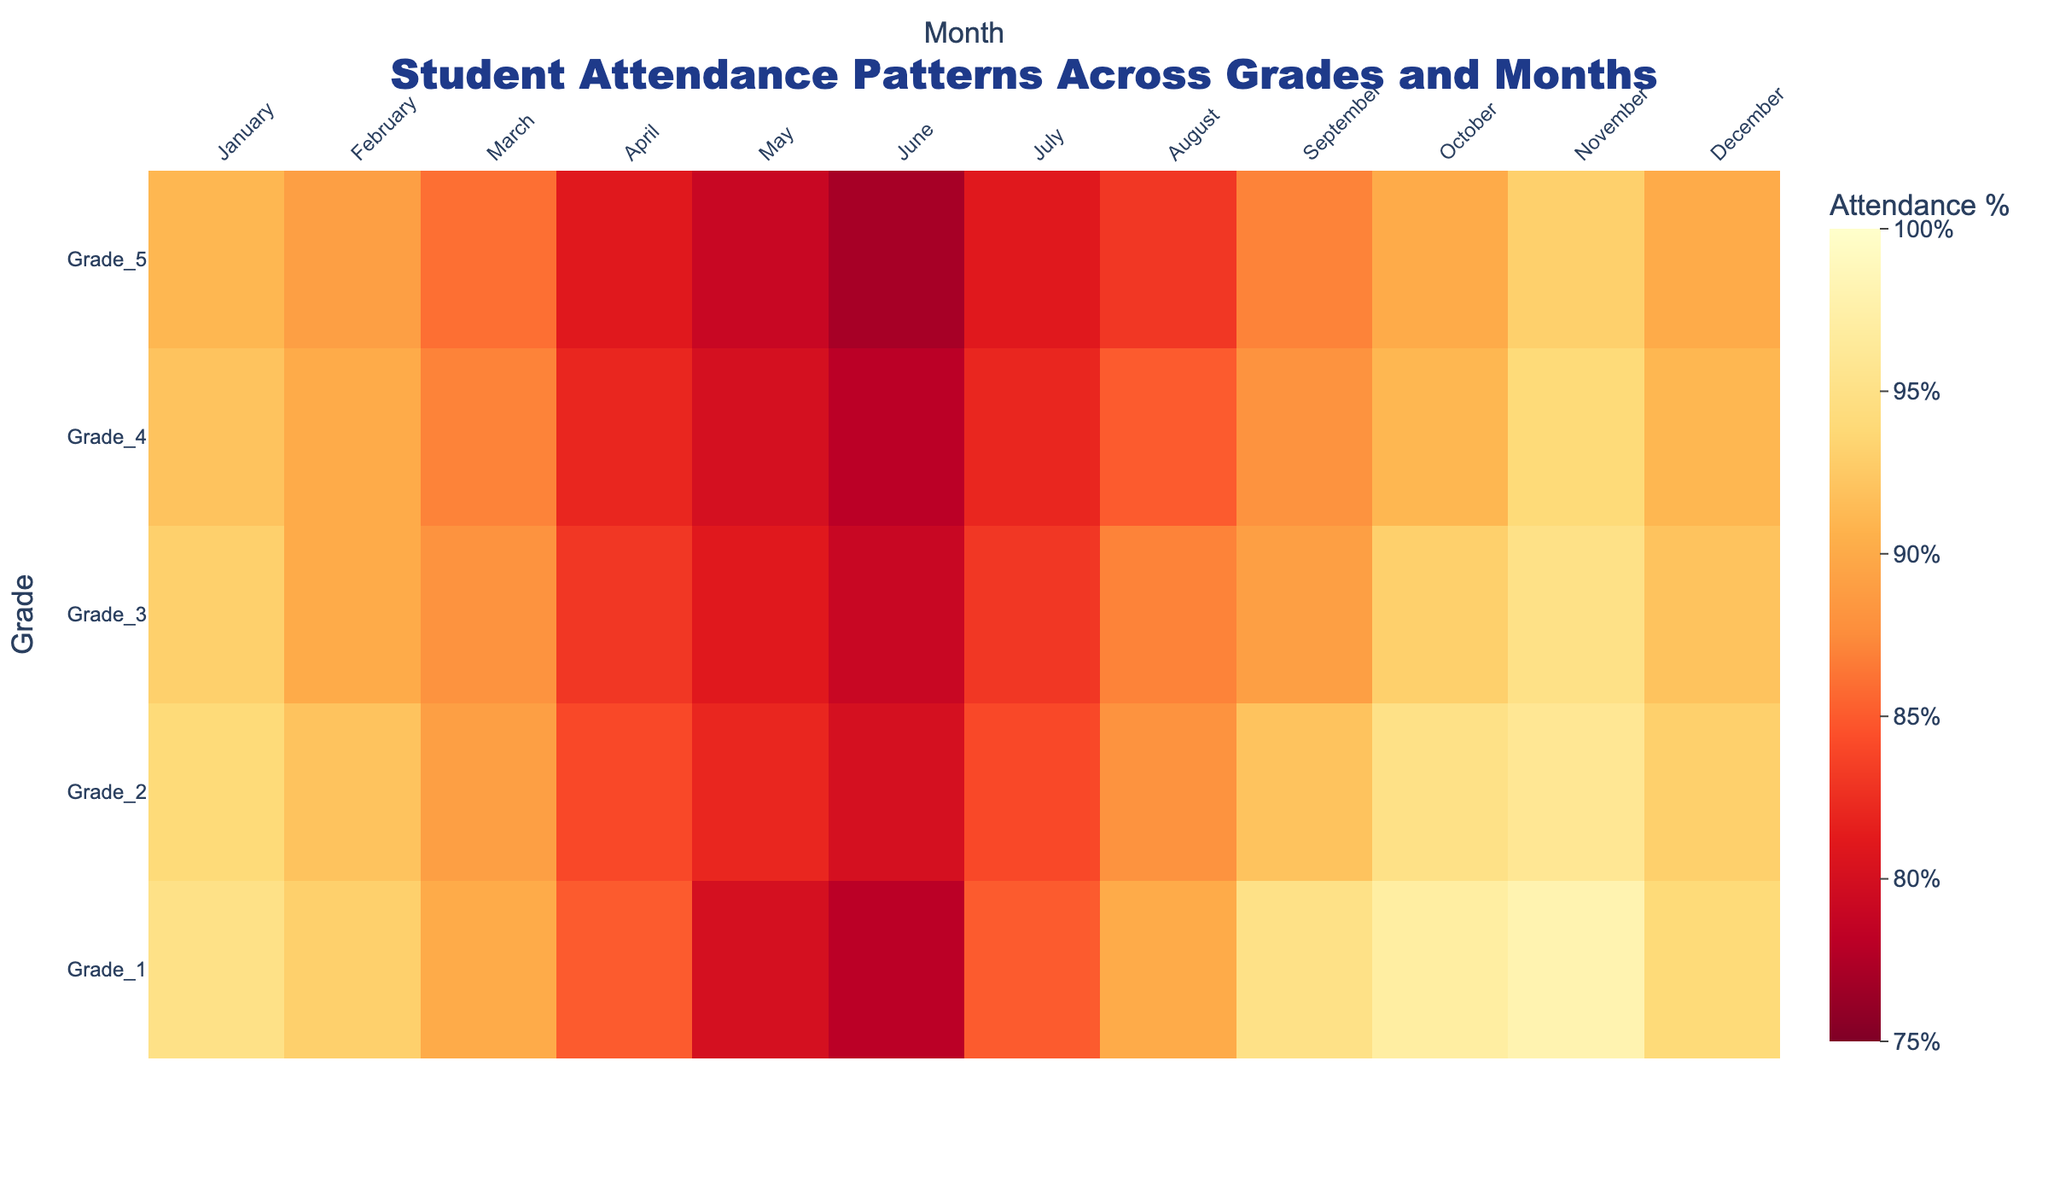What is the highest average attendance percentage in Grade 1 and in which month does it occur? By looking at the heatmap for Grade 1, the brightest color represents the highest attendance percentage, which is 98% in November.
Answer: 98% in November Which grade has the lowest average attendance percentage in June? To answer this, find the color representing June for the respective grades and identify the one with the lowest percentage, which is Grade 1 with 78%.
Answer: Grade 1 How does the attendance percentage in April compare between Grade 3 and Grade 4? Check the color shade for April in both Grade 3 and Grade 4. Grade 3 has 83%, lighter orange, and Grade 4 has 82%, a bit deeper orange, so Grade 3 is higher.
Answer: Grade 3 is higher Which month consistently shows lower attendance across all grades? Observe the overall color trend and note which month has the darkest shades on average. June is consistently the darkest across all grades.
Answer: June Is there any month where all grades have an attendance percentage above 90%? Look for a month where all squares are in lighter shades (high percentages). November shows light colors for all grades, indicating attendance above 90% for each.
Answer: November What is the attendance percentage difference between January and December in Grade 5? Identify and subtract the attendance percentages for January (91%) and December (90%) in Grade 5: 91% - 90% = 1%.
Answer: 1% In which month does Grade 2 have the highest attendance, and what is that percentage? Identify the lightest color square for Grade 2; November shows the lightest shade with 96%.
Answer: November, 96% Between May and October, which month shows a greater increase in attendance from June for Grade 4? Find the percentages: In May (80%) and October (91%) from June (78%). The increase for May is 2%, for October is 13% (more significant).
Answer: October Which grades have an average attendance percentage of 80% in May? Check the color corresponding to 80% for May in different grades. Grade 1, Grade 4, and Grade 5 each show 80%.
Answer: Grade 1, Grade 4, Grade 5 Does the attendance trend improve, decline, or remain stable from March to April for all grades? Compare March to April for each grade: each Grade’s percentage decreases (Grade 1: 90% to 85%, Grade 2: 89% to 84%, Grade 3: 88% to 83%, Grade 4: 87% to 82%, Grade 5: 86% to 81%).
Answer: Decline 